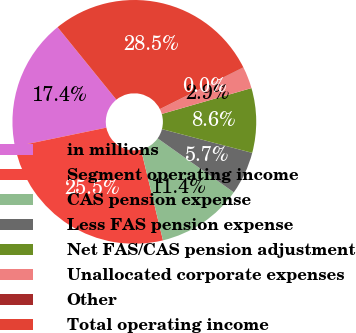<chart> <loc_0><loc_0><loc_500><loc_500><pie_chart><fcel>in millions<fcel>Segment operating income<fcel>CAS pension expense<fcel>Less FAS pension expense<fcel>Net FAS/CAS pension adjustment<fcel>Unallocated corporate expenses<fcel>Other<fcel>Total operating income<nl><fcel>17.4%<fcel>25.53%<fcel>11.41%<fcel>5.72%<fcel>8.56%<fcel>2.88%<fcel>0.03%<fcel>28.46%<nl></chart> 